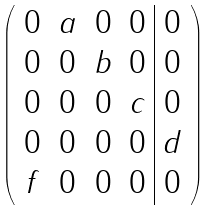Convert formula to latex. <formula><loc_0><loc_0><loc_500><loc_500>\left ( \begin{array} { c c c c | c } 0 & a & 0 & 0 & 0 \\ 0 & 0 & b & 0 & 0 \\ 0 & 0 & 0 & c & 0 \\ 0 & 0 & 0 & 0 & d \\ f & 0 & 0 & 0 & 0 \end{array} \right )</formula> 